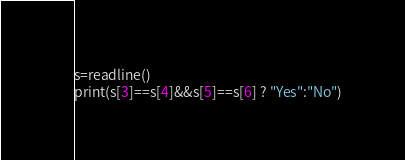Convert code to text. <code><loc_0><loc_0><loc_500><loc_500><_Julia_>s=readline()
print(s[3]==s[4]&&s[5]==s[6] ? "Yes":"No")</code> 